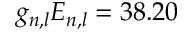<formula> <loc_0><loc_0><loc_500><loc_500>g _ { n , l } E _ { n , l } = 3 8 . 2 0</formula> 